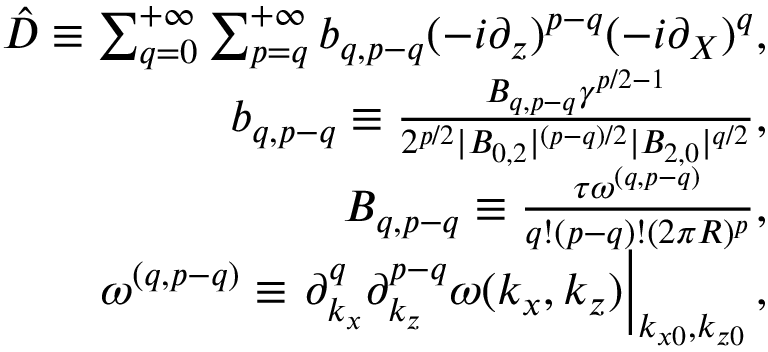<formula> <loc_0><loc_0><loc_500><loc_500>\begin{array} { r l r } & { \hat { D } \equiv \sum _ { q = 0 } ^ { + \infty } \sum _ { p = q } ^ { + \infty } b _ { q , p - q } ( - i \partial _ { z } ) ^ { p - q } ( - i \partial _ { X } ) ^ { q } , } \\ & { b _ { q , p - q } \equiv \frac { B _ { q , p - q } \gamma ^ { p / 2 - 1 } } { 2 ^ { p / 2 } | B _ { 0 , 2 } | ^ { ( p - q ) / 2 } | B _ { 2 , 0 } | ^ { q / 2 } } , } \\ & { B _ { q , p - q } \equiv \frac { \tau \omega ^ { ( q , p - q ) } } { q ! ( p - q ) ! ( 2 \pi R ) ^ { p } } , } \\ & { \omega ^ { ( q , p - q ) } \equiv \partial _ { k _ { x } } ^ { q } \partial _ { k _ { z } } ^ { p - q } \omega ( k _ { x } , k _ { z } ) \right | _ { k _ { x 0 } , k _ { z 0 } } , } \end{array}</formula> 